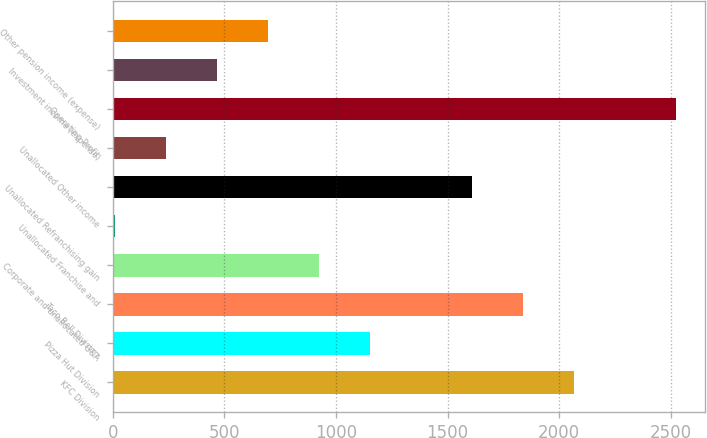Convert chart. <chart><loc_0><loc_0><loc_500><loc_500><bar_chart><fcel>KFC Division<fcel>Pizza Hut Division<fcel>Taco Bell Division<fcel>Corporate and unallocated G&A<fcel>Unallocated Franchise and<fcel>Unallocated Refranchising gain<fcel>Unallocated Other income<fcel>Operating Profit<fcel>Investment income (expense)<fcel>Other pension income (expense)<nl><fcel>2067.2<fcel>1152<fcel>1838.4<fcel>923.2<fcel>8<fcel>1609.6<fcel>236.8<fcel>2524.8<fcel>465.6<fcel>694.4<nl></chart> 